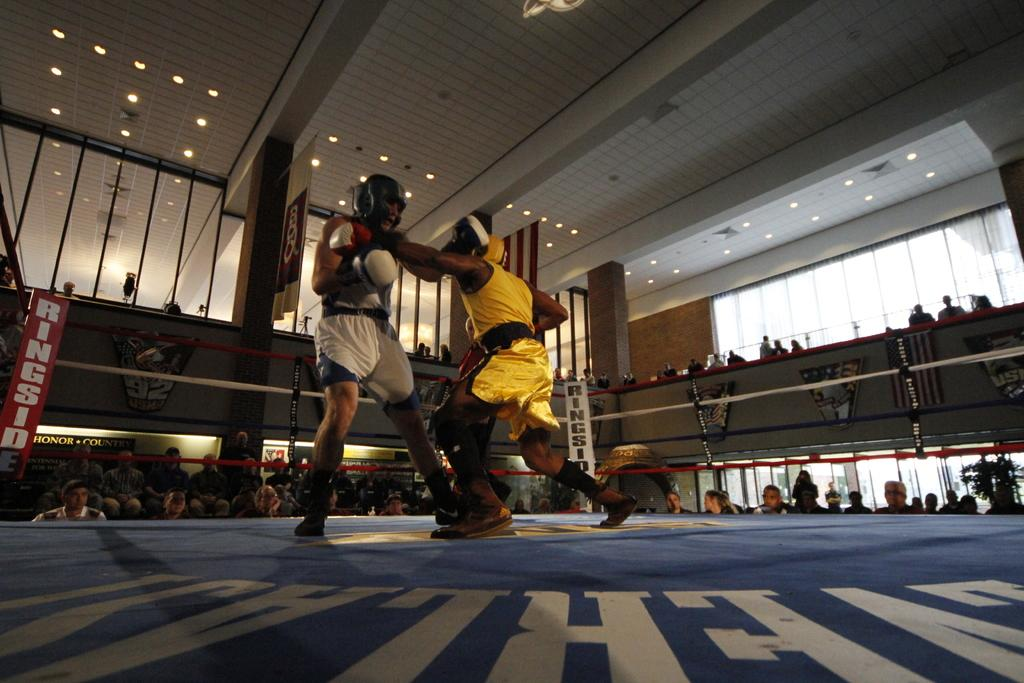<image>
Present a compact description of the photo's key features. People are boxing near a read sign that says Ringside on it. 